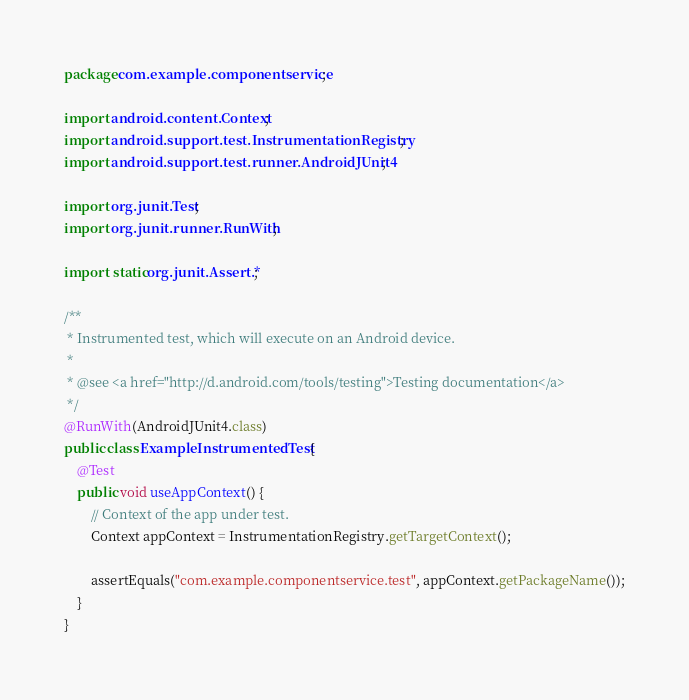Convert code to text. <code><loc_0><loc_0><loc_500><loc_500><_Java_>package com.example.componentservice;

import android.content.Context;
import android.support.test.InstrumentationRegistry;
import android.support.test.runner.AndroidJUnit4;

import org.junit.Test;
import org.junit.runner.RunWith;

import static org.junit.Assert.*;

/**
 * Instrumented test, which will execute on an Android device.
 *
 * @see <a href="http://d.android.com/tools/testing">Testing documentation</a>
 */
@RunWith(AndroidJUnit4.class)
public class ExampleInstrumentedTest {
    @Test
    public void useAppContext() {
        // Context of the app under test.
        Context appContext = InstrumentationRegistry.getTargetContext();

        assertEquals("com.example.componentservice.test", appContext.getPackageName());
    }
}
</code> 